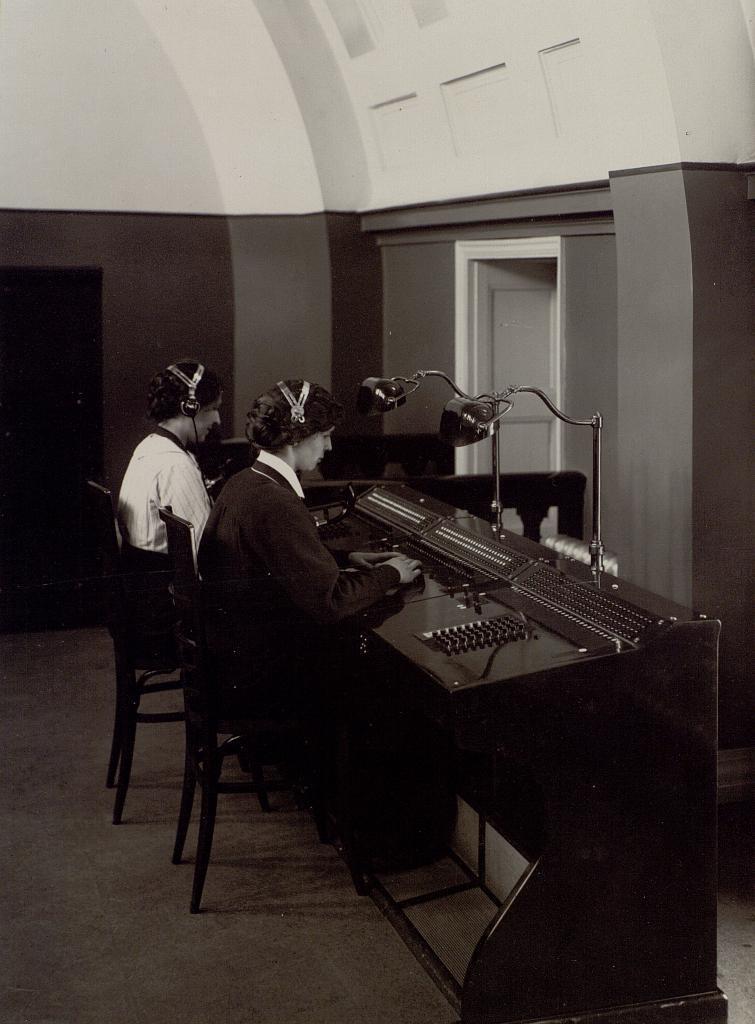In one or two sentences, can you explain what this image depicts? This is a black and white image, in this image in the center there are two persons sitting on chairs and they are typing something. In front of them there are keyboards on the table, and there are lights. In the background there are doors and wall, at the bottom there is floor. 